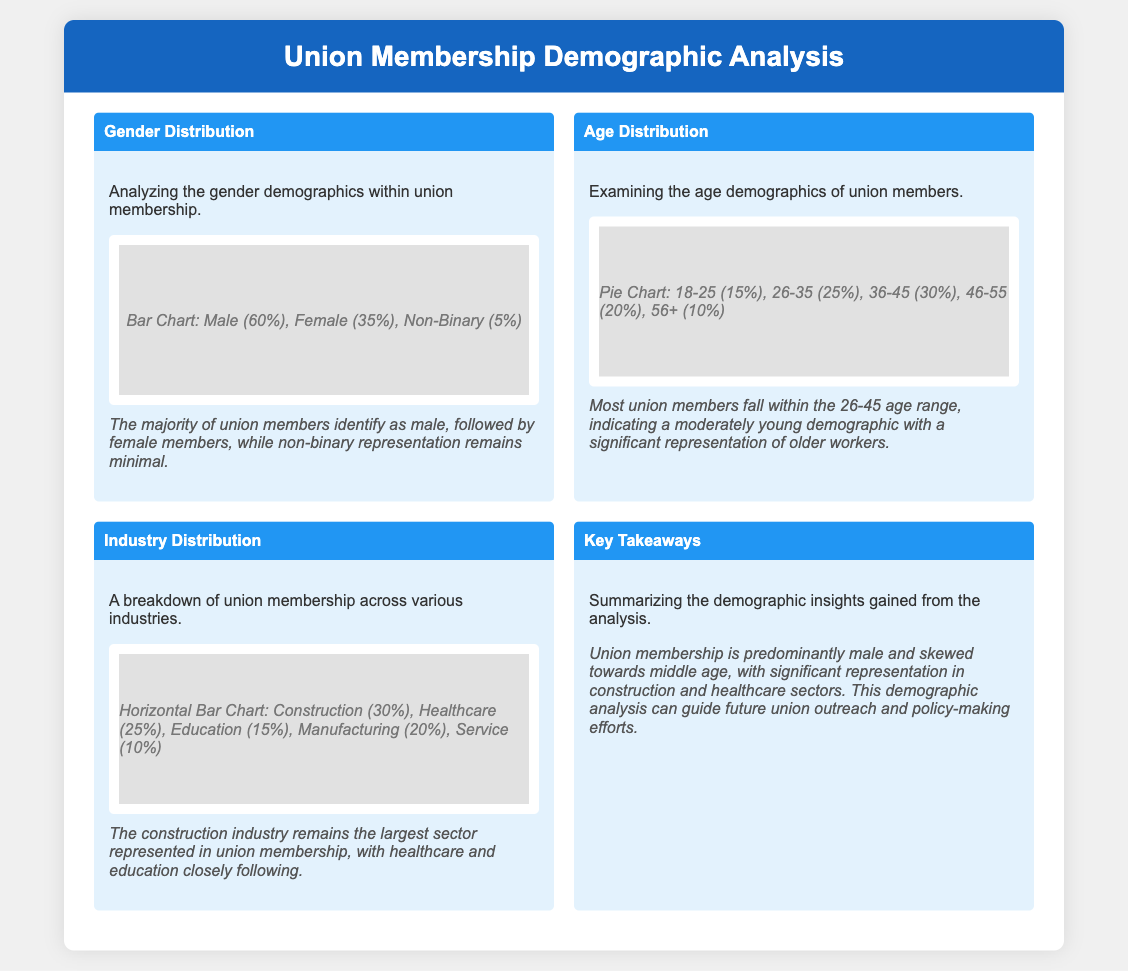What is the percentage of male union members? The document states that male union members make up 60% of the membership.
Answer: 60% What is the age range with the highest percentage of union members? According to the age distribution, the highest percentage falls in the 36-45 range, with 30%.
Answer: 36-45 Which industry has the largest representation in union membership? The document indicates that the construction industry has the largest representation at 30%.
Answer: Construction What percentage of union members are non-binary? The document specifies that non-binary members represent 5% of the union membership.
Answer: 5% What is the total percentage of members aged 56 and older? The document lists that 10% of union members are aged 56 and older.
Answer: 10% Which two industries closely follow construction in terms of representation? The document shows that healthcare (25%) and education (15%) closely follow construction in industry representation.
Answer: Healthcare and Education What demographic trend does the union membership suggest regarding gender? The analysis states that the majority of union members identify as male, indicating a gender imbalance.
Answer: Male dominance How many age groups are represented in the age distribution chart? The document outlines five age groups in the age distribution chart.
Answer: Five What insights are drawn about the union membership's age demographic? The document notes that most union members fall within the 26-45 age range, suggesting a moderately young demographic.
Answer: Moderately young demographic 